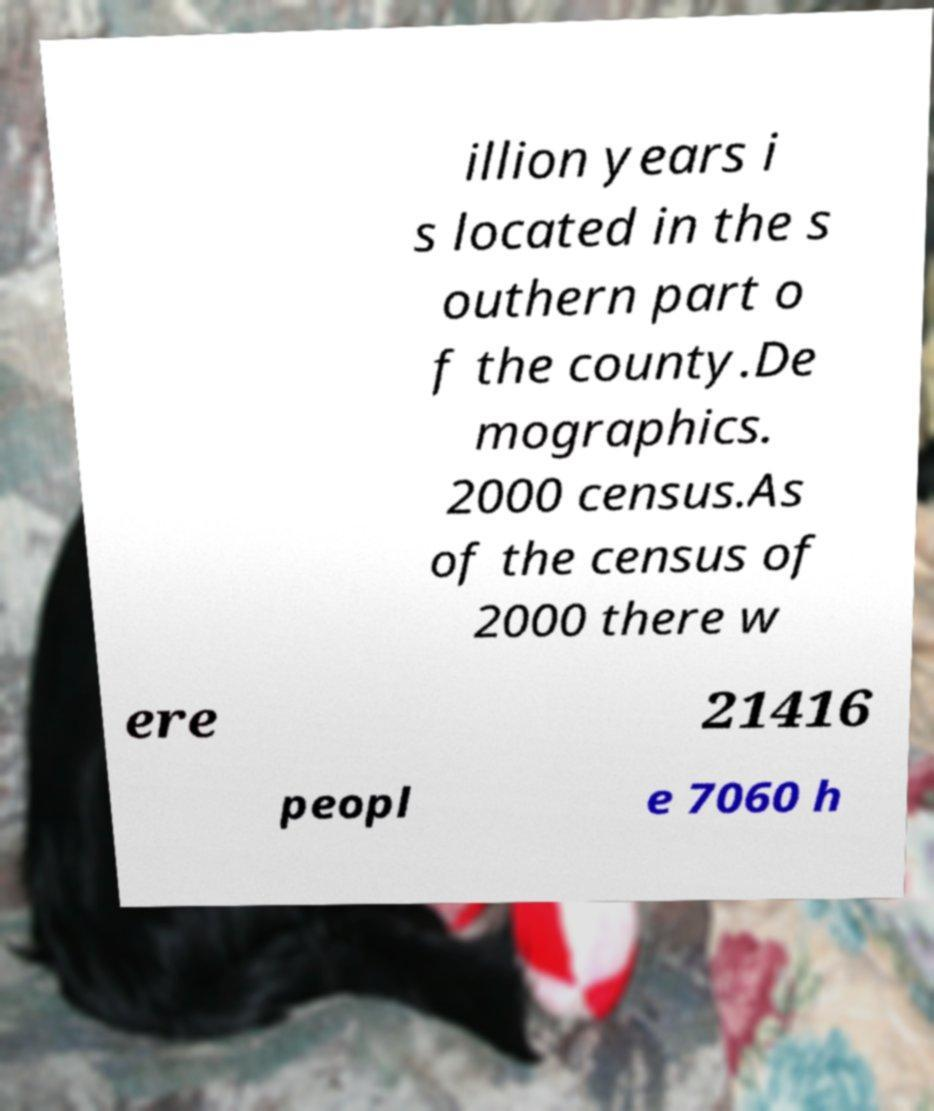I need the written content from this picture converted into text. Can you do that? illion years i s located in the s outhern part o f the county.De mographics. 2000 census.As of the census of 2000 there w ere 21416 peopl e 7060 h 